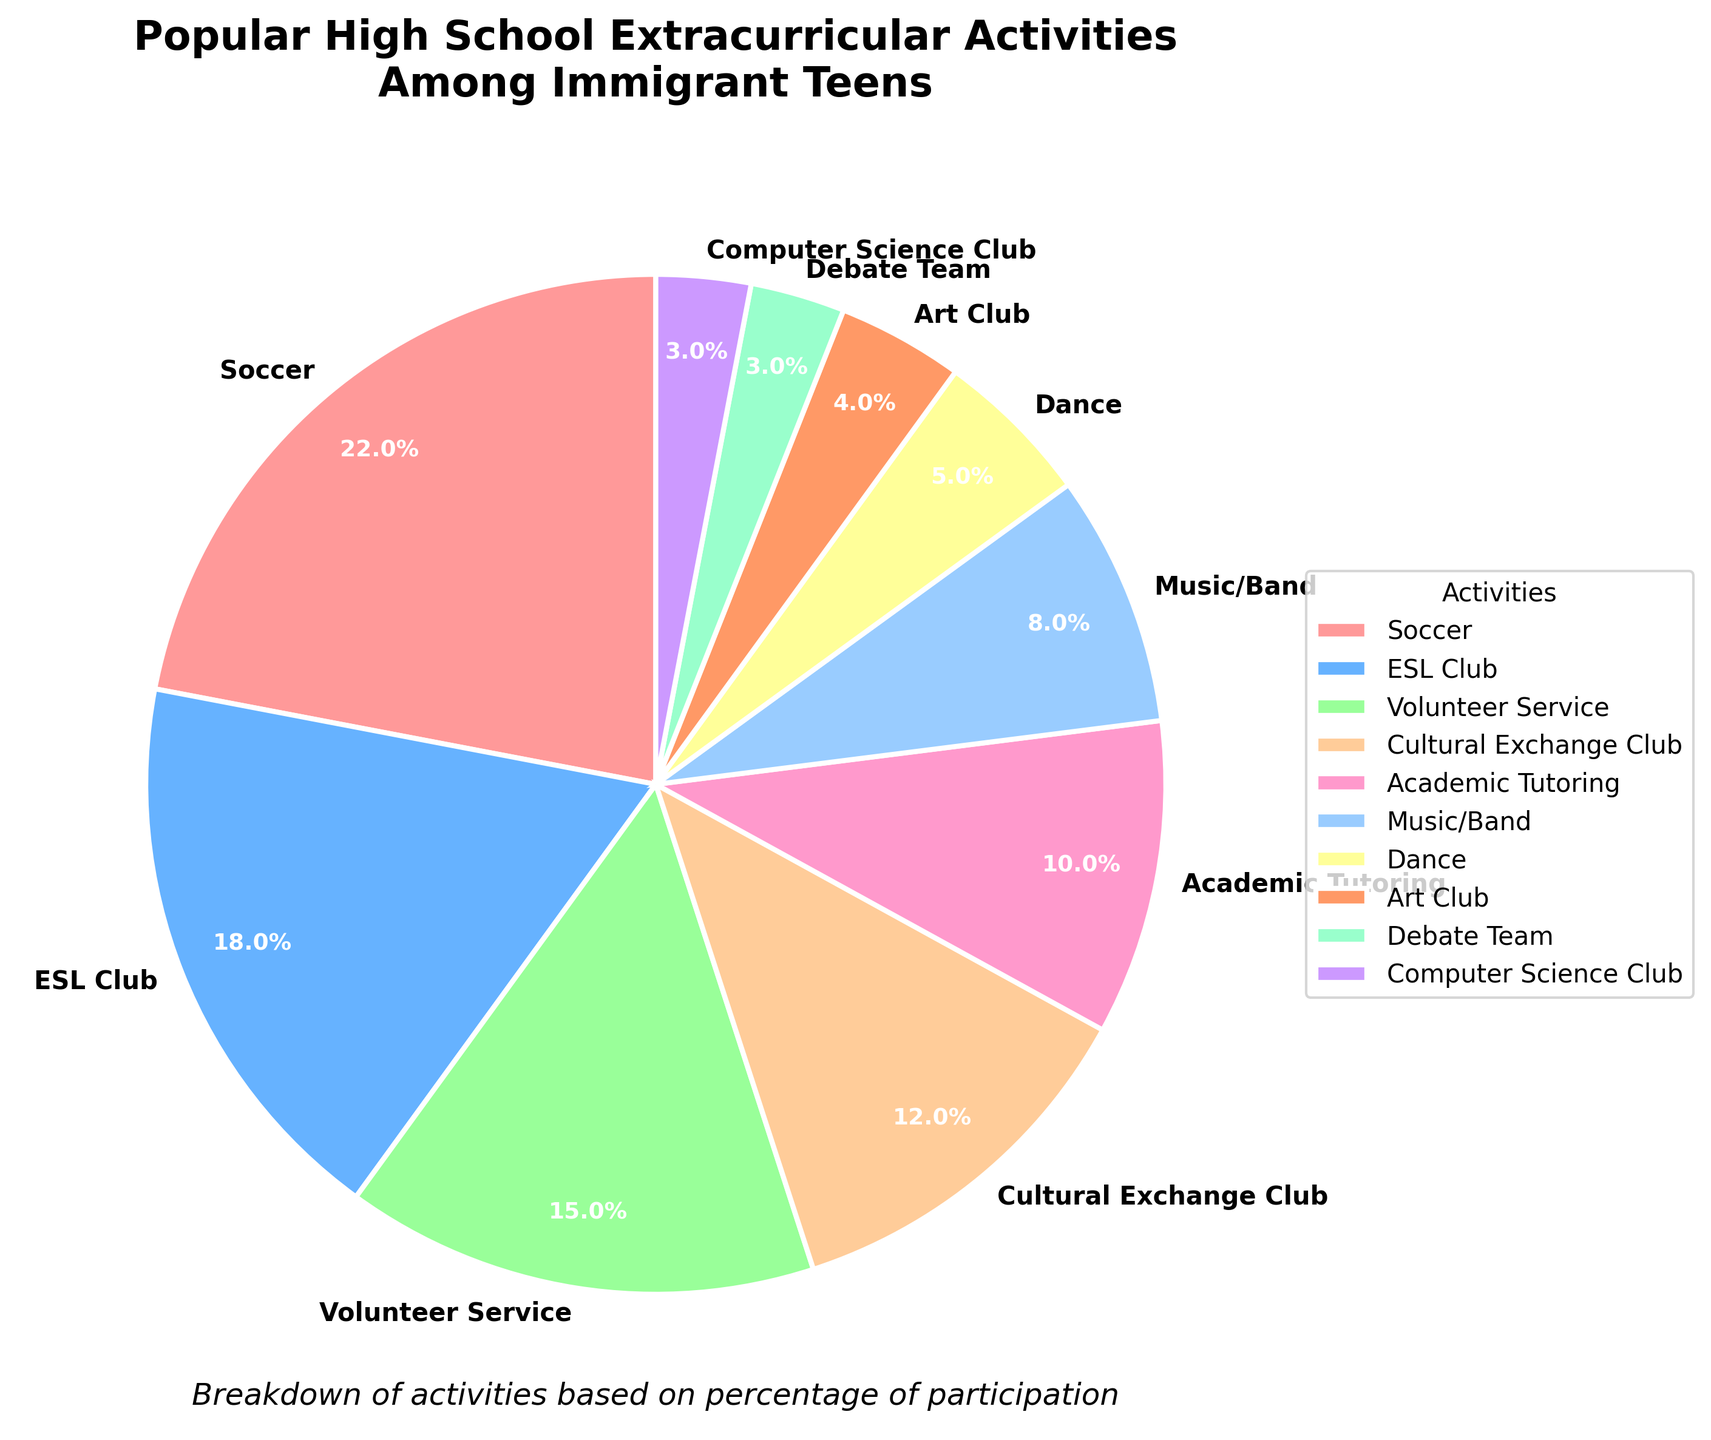What activity has the highest participation percentage? The pie chart shows several activities with their respective percentages. The one with the highest percentage should be the largest slice.
Answer: Soccer Which two activities have the smallest percentage participation and what is the combined percentage? Identify the two smallest slices in the pie chart, add their percentages together. The smallest slices represent the Debate Team and Computer Science Club, each with 3%, so combined it's 3% + 3% = 6%.
Answer: Debate Team, Computer Science Club, 6% Compare the participation in Music/Band and Dance. Which one is more popular and by how much? Look for the slices labeled "Music/Band" and "Dance." Music/Band has 8% and Dance has 5%. The difference is 8% - 5% = 3%.
Answer: Music/Band, 3% What is the total percentage for artistic activities (Music/Band, Dance, Art Club)? Sum the percentages for Music/Band (8%), Dance (5%), and Art Club (4%). The total is 8% + 5% + 4% = 17%.
Answer: 17% How does the participation in ESL Club compare to Academic Tutoring? Look at the slices for ESL Club (18%) and Academic Tutoring (10%). ESL Club is more popular. The difference is 18% - 10% = 8%.
Answer: ESL Club, 8% Which activities have a participation rate greater than 15%? Identify the slices with percentages greater than 15%. These are Soccer (22%) and ESL Club (18%).
Answer: Soccer, ESL Club What is the difference in percentage between the most and least popular activities? The most popular activity is Soccer (22%) and the least popular are Debate Team and Computer Science Club (3% each). The difference is 22% - 3% = 19%.
Answer: 19% What is the percentage for the three most popular activities combined? Sum the percentages for the top three activities: Soccer (22%), ESL Club (18%), and Volunteer Service (15%). The total is 22% + 18% + 15% = 55%.
Answer: 55% If you add the percentage of Soccer and Volunteer Service, how does it compare to the total for Computer Science Club, Dance, and Art Club combined? Soccer (22%) + Volunteer Service (15%) = 37%. Computer Science Club (3%) + Dance (5%) + Art Club (4%) = 12%. Compare 37% to 12%.
Answer: 37% is greater by 25% How many activities have a participation rate below 10%? Count the slices with percentages less than 10%. These are Music/Band (8%), Dance (5%), Art Club (4%), Debate Team (3%), and Computer Science Club (3%), so 5 activities.
Answer: 5 